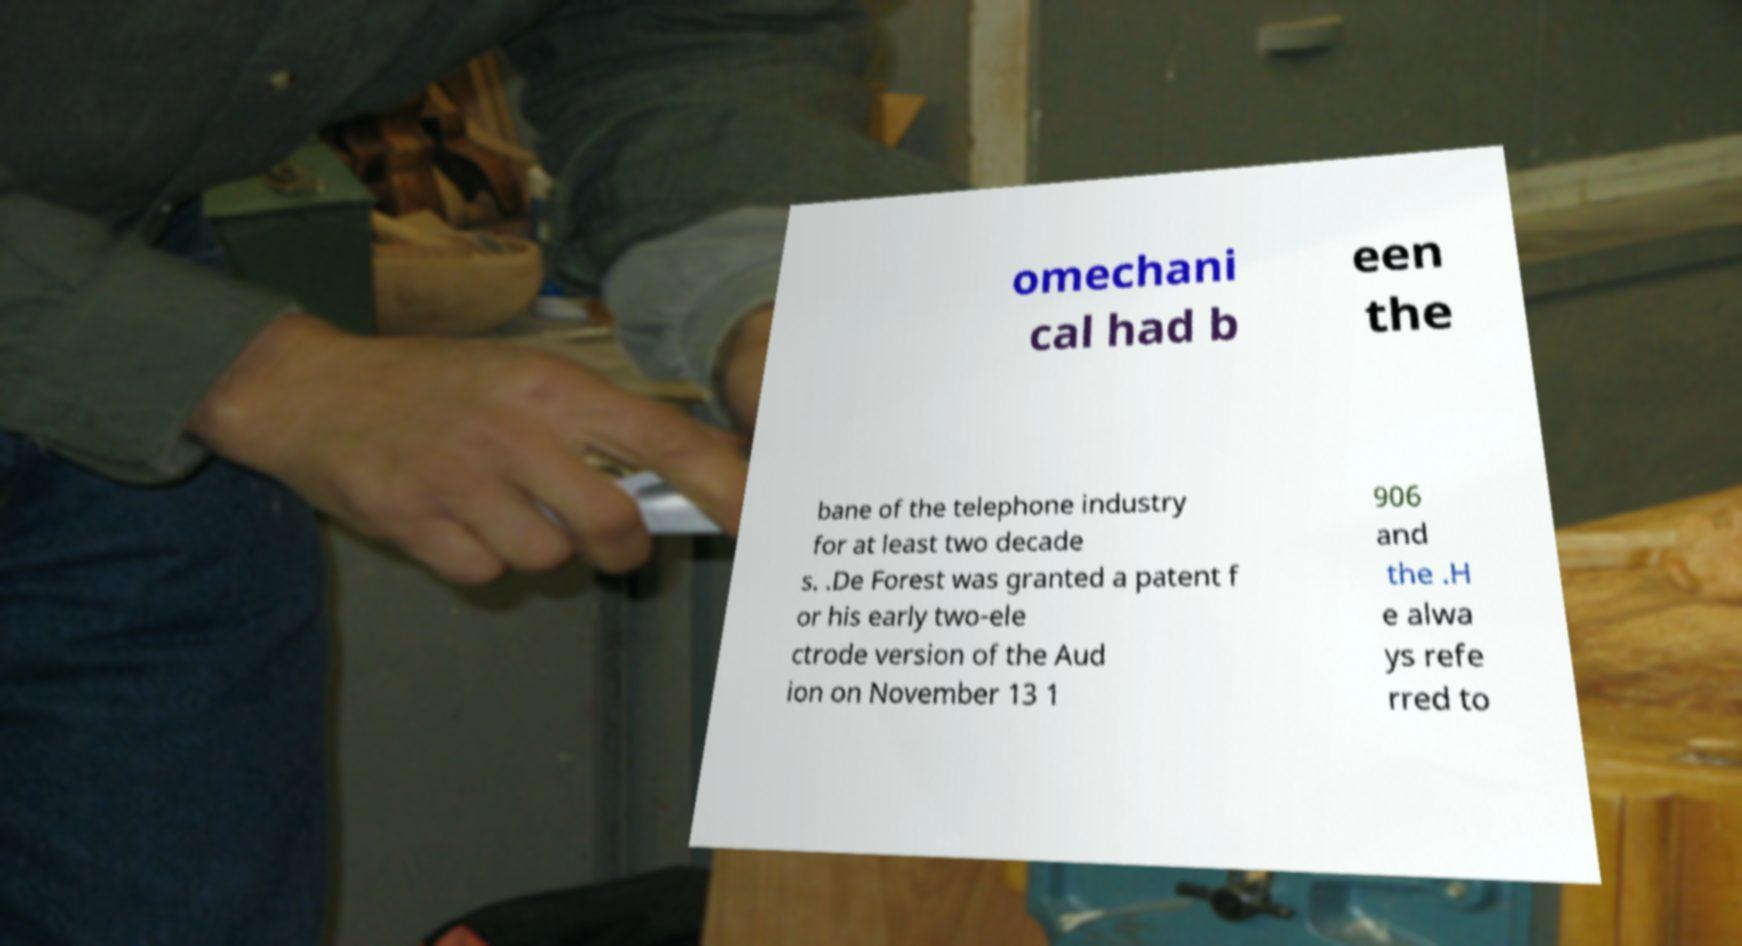I need the written content from this picture converted into text. Can you do that? omechani cal had b een the bane of the telephone industry for at least two decade s. .De Forest was granted a patent f or his early two-ele ctrode version of the Aud ion on November 13 1 906 and the .H e alwa ys refe rred to 